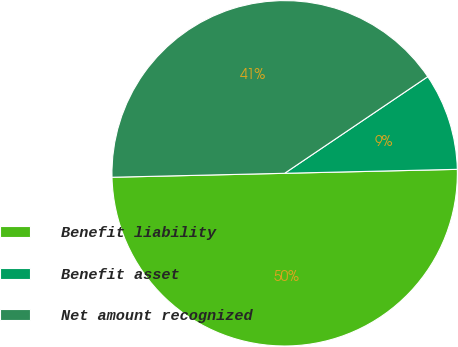Convert chart to OTSL. <chart><loc_0><loc_0><loc_500><loc_500><pie_chart><fcel>Benefit liability<fcel>Benefit asset<fcel>Net amount recognized<nl><fcel>50.0%<fcel>9.09%<fcel>40.91%<nl></chart> 